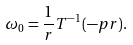<formula> <loc_0><loc_0><loc_500><loc_500>\omega _ { 0 } = \frac { 1 } { r } T ^ { - 1 } ( - p r ) .</formula> 